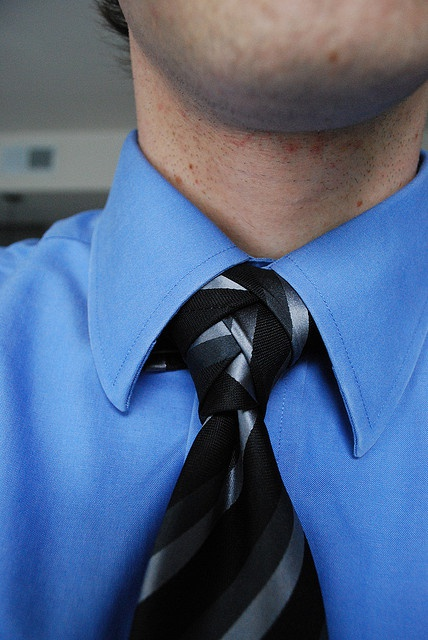Describe the objects in this image and their specific colors. I can see people in darkgray, black, purple, gray, and blue tones and tie in purple, black, navy, blue, and gray tones in this image. 